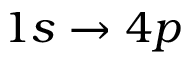Convert formula to latex. <formula><loc_0><loc_0><loc_500><loc_500>1 s \to 4 p</formula> 